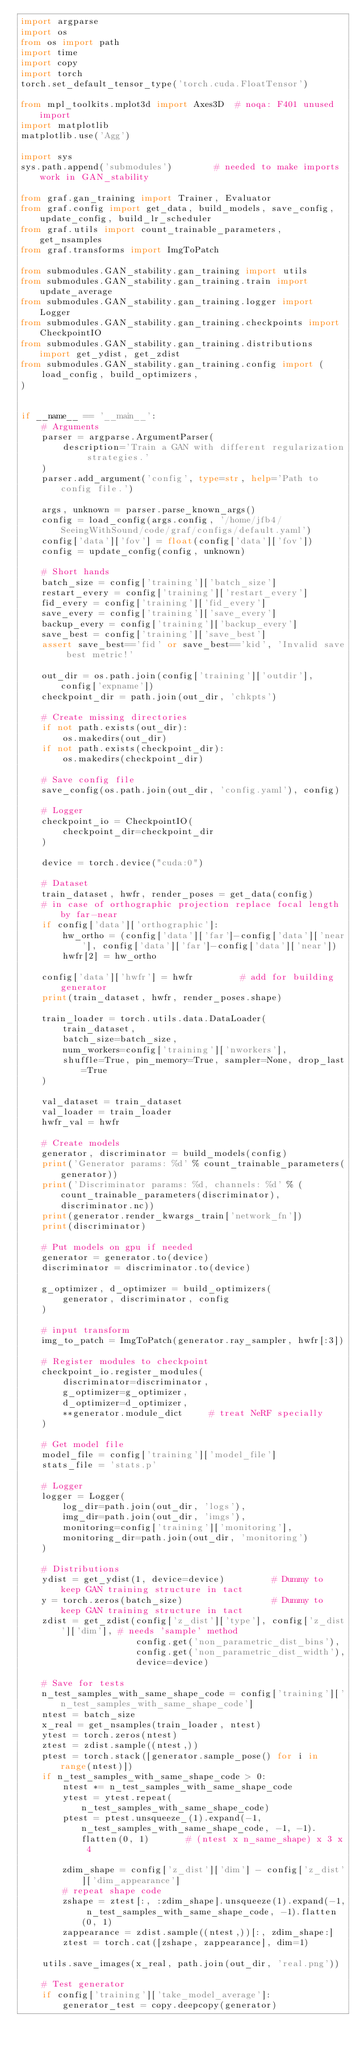<code> <loc_0><loc_0><loc_500><loc_500><_Python_>import argparse
import os
from os import path
import time
import copy
import torch
torch.set_default_tensor_type('torch.cuda.FloatTensor')

from mpl_toolkits.mplot3d import Axes3D  # noqa: F401 unused import
import matplotlib
matplotlib.use('Agg')

import sys
sys.path.append('submodules')        # needed to make imports work in GAN_stability

from graf.gan_training import Trainer, Evaluator
from graf.config import get_data, build_models, save_config, update_config, build_lr_scheduler
from graf.utils import count_trainable_parameters, get_nsamples
from graf.transforms import ImgToPatch

from submodules.GAN_stability.gan_training import utils
from submodules.GAN_stability.gan_training.train import update_average
from submodules.GAN_stability.gan_training.logger import Logger
from submodules.GAN_stability.gan_training.checkpoints import CheckpointIO
from submodules.GAN_stability.gan_training.distributions import get_ydist, get_zdist
from submodules.GAN_stability.gan_training.config import (
    load_config, build_optimizers,
)


if __name__ == '__main__':
    # Arguments
    parser = argparse.ArgumentParser(
        description='Train a GAN with different regularization strategies.'
    )
    parser.add_argument('config', type=str, help='Path to config file.')

    args, unknown = parser.parse_known_args() 
    config = load_config(args.config, '/home/jfb4/SeeingWithSound/code/graf/configs/default.yaml')
    config['data']['fov'] = float(config['data']['fov'])
    config = update_config(config, unknown)

    # Short hands
    batch_size = config['training']['batch_size']
    restart_every = config['training']['restart_every']
    fid_every = config['training']['fid_every']
    save_every = config['training']['save_every']
    backup_every = config['training']['backup_every']
    save_best = config['training']['save_best']
    assert save_best=='fid' or save_best=='kid', 'Invalid save best metric!'

    out_dir = os.path.join(config['training']['outdir'], config['expname'])
    checkpoint_dir = path.join(out_dir, 'chkpts')

    # Create missing directories
    if not path.exists(out_dir):
        os.makedirs(out_dir)
    if not path.exists(checkpoint_dir):
        os.makedirs(checkpoint_dir)

    # Save config file
    save_config(os.path.join(out_dir, 'config.yaml'), config)

    # Logger
    checkpoint_io = CheckpointIO(
        checkpoint_dir=checkpoint_dir
    )

    device = torch.device("cuda:0")

    # Dataset
    train_dataset, hwfr, render_poses = get_data(config)
    # in case of orthographic projection replace focal length by far-near
    if config['data']['orthographic']:
        hw_ortho = (config['data']['far']-config['data']['near'], config['data']['far']-config['data']['near'])
        hwfr[2] = hw_ortho

    config['data']['hwfr'] = hwfr         # add for building generator
    print(train_dataset, hwfr, render_poses.shape)

    train_loader = torch.utils.data.DataLoader(
        train_dataset,
        batch_size=batch_size,
        num_workers=config['training']['nworkers'],
        shuffle=True, pin_memory=True, sampler=None, drop_last=True
    )

    val_dataset = train_dataset
    val_loader = train_loader
    hwfr_val = hwfr

    # Create models
    generator, discriminator = build_models(config)
    print('Generator params: %d' % count_trainable_parameters(generator))
    print('Discriminator params: %d, channels: %d' % (count_trainable_parameters(discriminator), discriminator.nc))
    print(generator.render_kwargs_train['network_fn'])
    print(discriminator)

    # Put models on gpu if needed
    generator = generator.to(device)
    discriminator = discriminator.to(device)

    g_optimizer, d_optimizer = build_optimizers(
        generator, discriminator, config
    )

    # input transform
    img_to_patch = ImgToPatch(generator.ray_sampler, hwfr[:3])

    # Register modules to checkpoint
    checkpoint_io.register_modules(
        discriminator=discriminator,
        g_optimizer=g_optimizer,
        d_optimizer=d_optimizer,
        **generator.module_dict     # treat NeRF specially
    )
    
    # Get model file
    model_file = config['training']['model_file']
    stats_file = 'stats.p'

    # Logger
    logger = Logger(
        log_dir=path.join(out_dir, 'logs'),
        img_dir=path.join(out_dir, 'imgs'),
        monitoring=config['training']['monitoring'],
        monitoring_dir=path.join(out_dir, 'monitoring')
    )

    # Distributions
    ydist = get_ydist(1, device=device)         # Dummy to keep GAN training structure in tact
    y = torch.zeros(batch_size)                 # Dummy to keep GAN training structure in tact
    zdist = get_zdist(config['z_dist']['type'], config['z_dist']['dim'], # needs 'sample' method
                      config.get('non_parametric_dist_bins'), 
                      config.get('non_parametric_dist_width'),
                      device=device) 

    # Save for tests
    n_test_samples_with_same_shape_code = config['training']['n_test_samples_with_same_shape_code']
    ntest = batch_size
    x_real = get_nsamples(train_loader, ntest)
    ytest = torch.zeros(ntest)
    ztest = zdist.sample((ntest,))
    ptest = torch.stack([generator.sample_pose() for i in range(ntest)])
    if n_test_samples_with_same_shape_code > 0:
        ntest *= n_test_samples_with_same_shape_code
        ytest = ytest.repeat(n_test_samples_with_same_shape_code)
        ptest = ptest.unsqueeze_(1).expand(-1, n_test_samples_with_same_shape_code, -1, -1).flatten(0, 1)       # (ntest x n_same_shape) x 3 x 4

        zdim_shape = config['z_dist']['dim'] - config['z_dist']['dim_appearance']
        # repeat shape code
        zshape = ztest[:, :zdim_shape].unsqueeze(1).expand(-1, n_test_samples_with_same_shape_code, -1).flatten(0, 1)
        zappearance = zdist.sample((ntest,))[:, zdim_shape:]
        ztest = torch.cat([zshape, zappearance], dim=1)

    utils.save_images(x_real, path.join(out_dir, 'real.png'))

    # Test generator
    if config['training']['take_model_average']:
        generator_test = copy.deepcopy(generator)</code> 